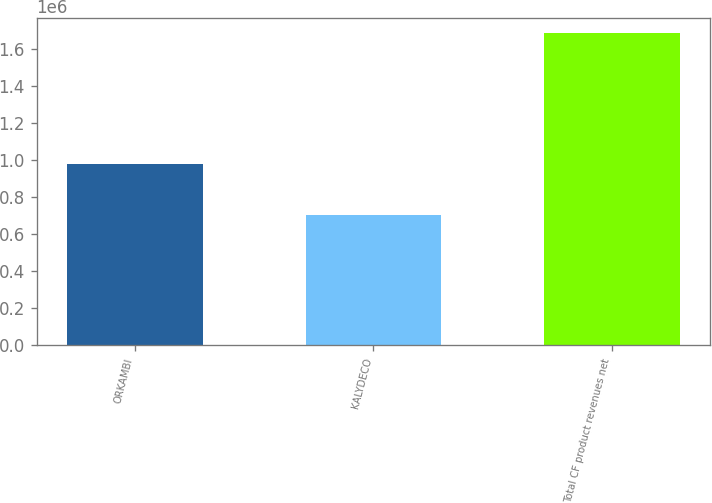<chart> <loc_0><loc_0><loc_500><loc_500><bar_chart><fcel>ORKAMBI<fcel>KALYDECO<fcel>Total CF product revenues net<nl><fcel>979590<fcel>703432<fcel>1.68302e+06<nl></chart> 